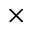<formula> <loc_0><loc_0><loc_500><loc_500>\times</formula> 